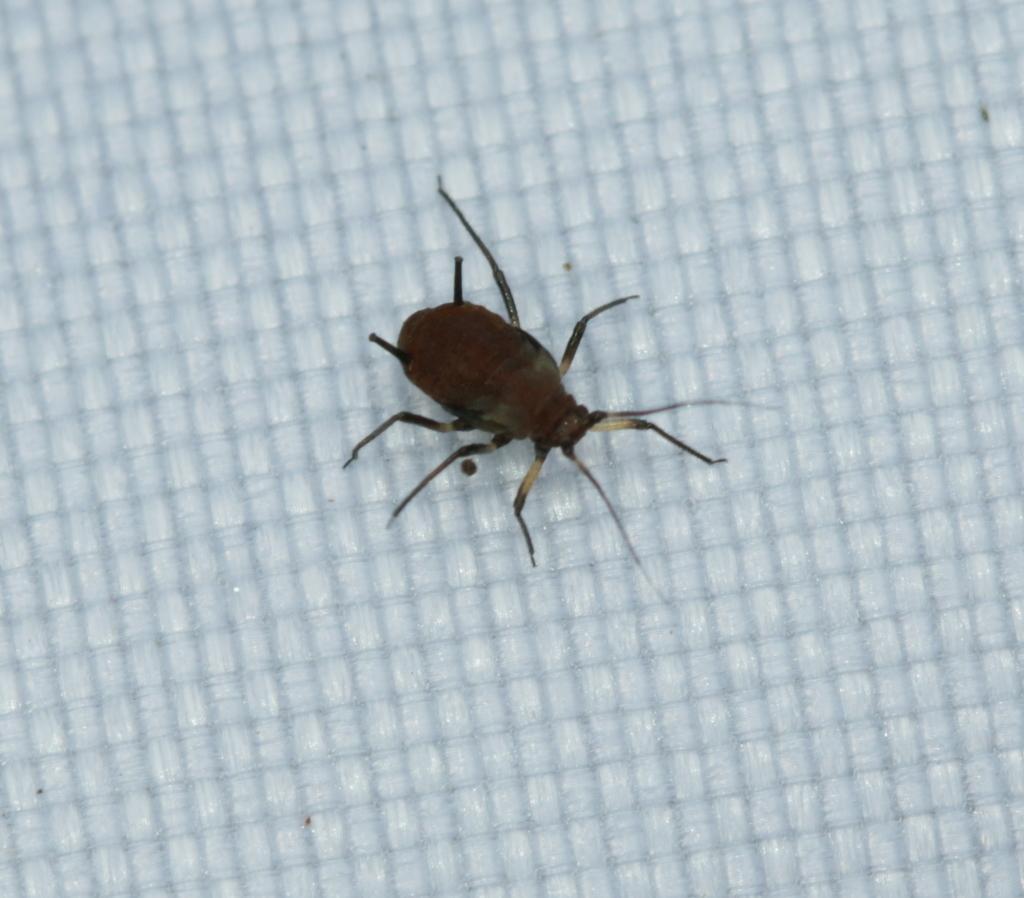How would you summarize this image in a sentence or two? In this image there is an insect. 